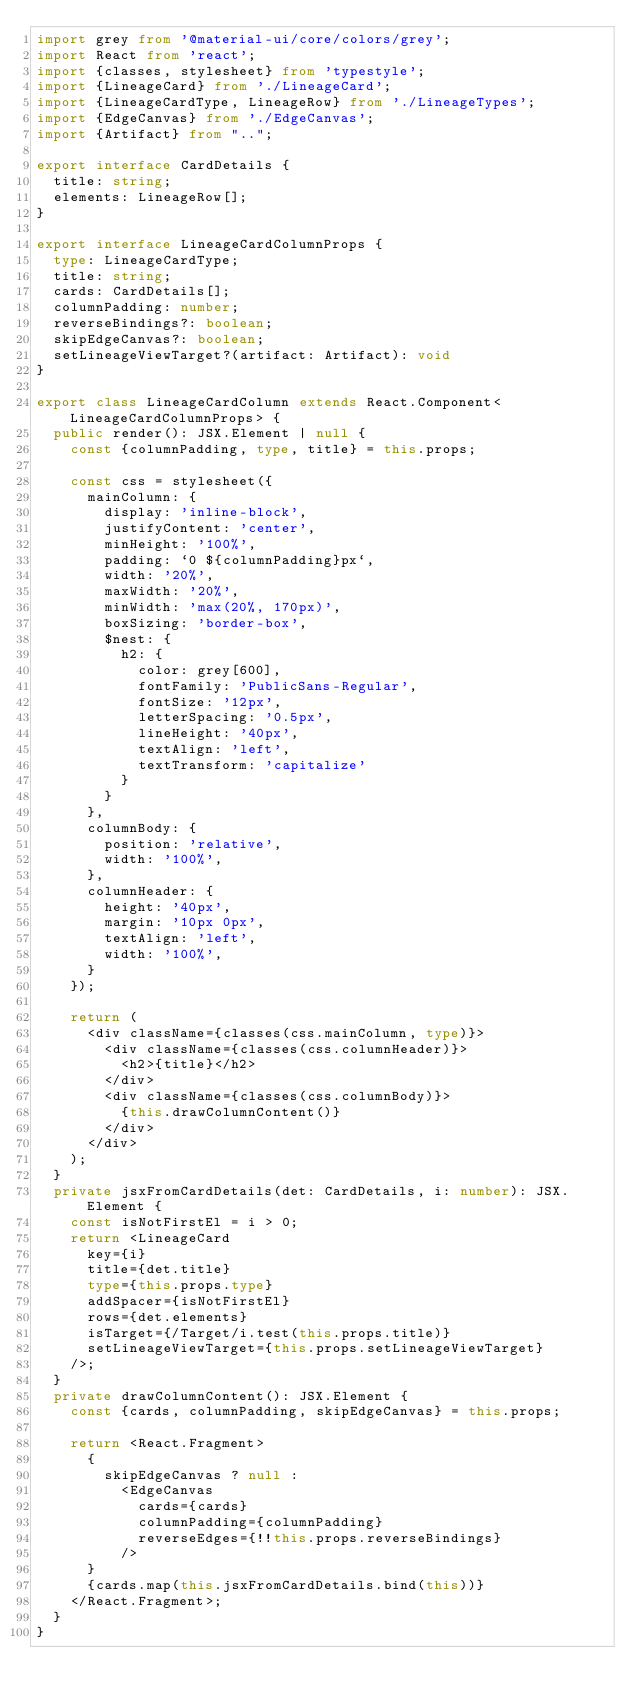<code> <loc_0><loc_0><loc_500><loc_500><_TypeScript_>import grey from '@material-ui/core/colors/grey';
import React from 'react';
import {classes, stylesheet} from 'typestyle';
import {LineageCard} from './LineageCard';
import {LineageCardType, LineageRow} from './LineageTypes';
import {EdgeCanvas} from './EdgeCanvas';
import {Artifact} from "..";

export interface CardDetails {
  title: string;
  elements: LineageRow[];
}

export interface LineageCardColumnProps {
  type: LineageCardType;
  title: string;
  cards: CardDetails[];
  columnPadding: number;
  reverseBindings?: boolean;
  skipEdgeCanvas?: boolean;
  setLineageViewTarget?(artifact: Artifact): void
}

export class LineageCardColumn extends React.Component<LineageCardColumnProps> {
  public render(): JSX.Element | null {
    const {columnPadding, type, title} = this.props;

    const css = stylesheet({
      mainColumn: {
        display: 'inline-block',
        justifyContent: 'center',
        minHeight: '100%',
        padding: `0 ${columnPadding}px`,
        width: '20%',
        maxWidth: '20%',
        minWidth: 'max(20%, 170px)',
        boxSizing: 'border-box',
        $nest: {
          h2: {
            color: grey[600],
            fontFamily: 'PublicSans-Regular',
            fontSize: '12px',
            letterSpacing: '0.5px',
            lineHeight: '40px',
            textAlign: 'left',
            textTransform: 'capitalize'
          }
        }
      },
      columnBody: {
        position: 'relative',
        width: '100%',
      },
      columnHeader: {
        height: '40px',
        margin: '10px 0px',
        textAlign: 'left',
        width: '100%',
      }
    });

    return (
      <div className={classes(css.mainColumn, type)}>
        <div className={classes(css.columnHeader)}>
          <h2>{title}</h2>
        </div>
        <div className={classes(css.columnBody)}>
          {this.drawColumnContent()}
        </div>
      </div>
    );
  }
  private jsxFromCardDetails(det: CardDetails, i: number): JSX.Element {
    const isNotFirstEl = i > 0;
    return <LineageCard
      key={i}
      title={det.title}
      type={this.props.type}
      addSpacer={isNotFirstEl}
      rows={det.elements}
      isTarget={/Target/i.test(this.props.title)}
      setLineageViewTarget={this.props.setLineageViewTarget}
    />;
  }
  private drawColumnContent(): JSX.Element {
    const {cards, columnPadding, skipEdgeCanvas} = this.props;

    return <React.Fragment>
      {
        skipEdgeCanvas ? null :
          <EdgeCanvas
            cards={cards}
            columnPadding={columnPadding}
            reverseEdges={!!this.props.reverseBindings}
          />
      }
      {cards.map(this.jsxFromCardDetails.bind(this))}
    </React.Fragment>;
  }
}
</code> 